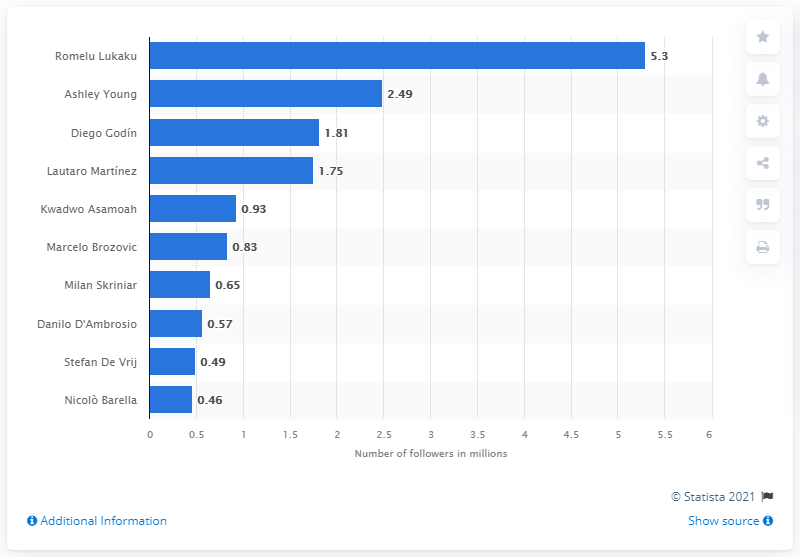Highlight a few significant elements in this photo. As of February 2023, Romelu Lukaku had 5.3 million followers on his social media accounts. As of May 29, 2020, Ashley Young was the second most popular player on Instagram. 